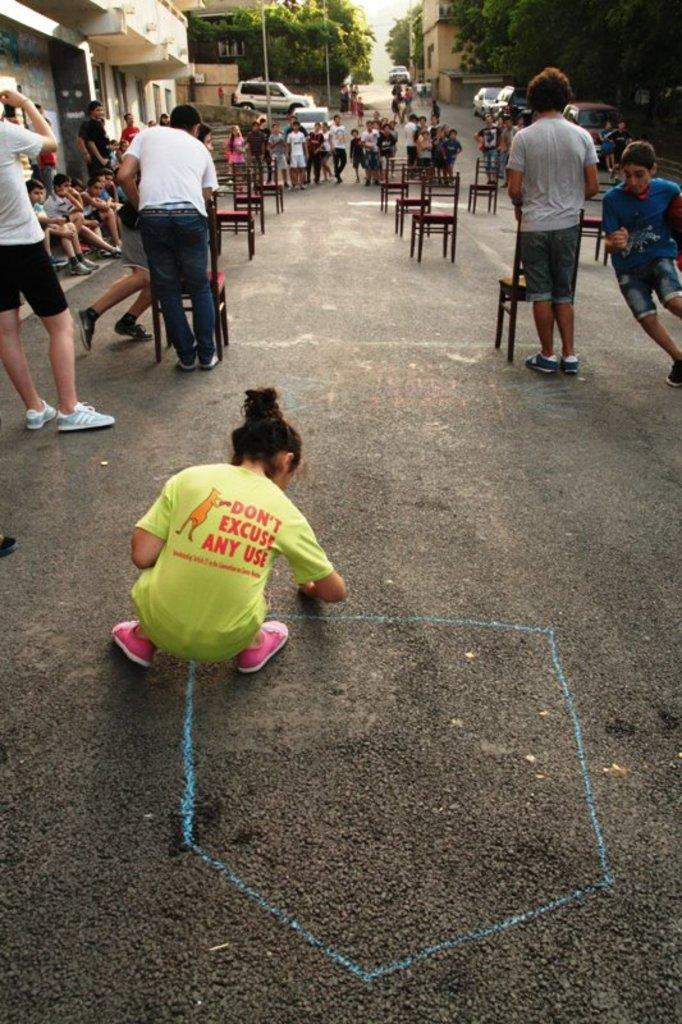How many people are present in the image? There are people in the image, but the exact number is not specified. What are the people doing in the image? Some people are playing a game on the road. What type of furniture is visible in the image? There are chairs in the image. What can be seen in the background of the image? There are trees, houses, vehicles, and poles in the background of the image. What type of potato is being grown in the image? There is no potato present in the image. 